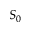Convert formula to latex. <formula><loc_0><loc_0><loc_500><loc_500>S _ { 0 }</formula> 